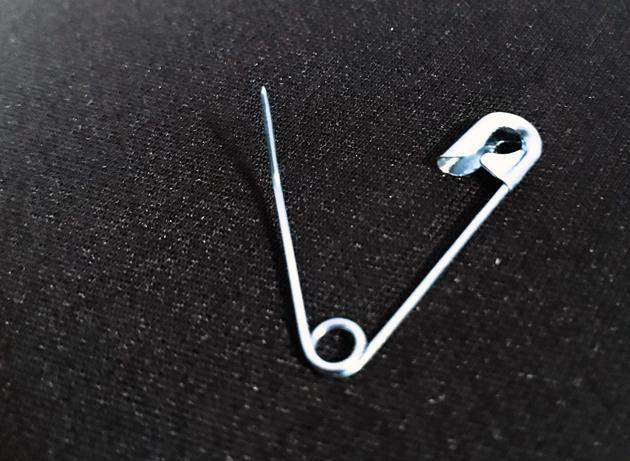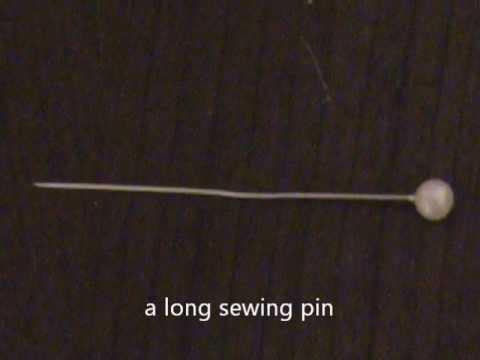The first image is the image on the left, the second image is the image on the right. Considering the images on both sides, is "At least one safety pin is pinned through a fabric." valid? Answer yes or no. No. The first image is the image on the left, the second image is the image on the right. Examine the images to the left and right. Is the description "An image contains one horizontal silver pin pierced through a solid color material." accurate? Answer yes or no. No. 